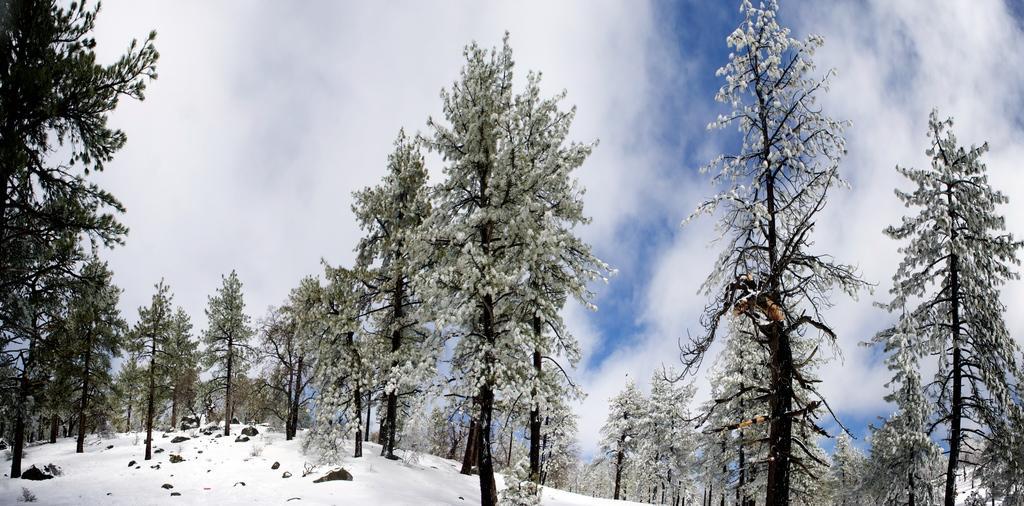In one or two sentences, can you explain what this image depicts? At the bottom of the image we can see the snow and rocks. In the background of the image we can see the trees and clouds are present in the sky. 